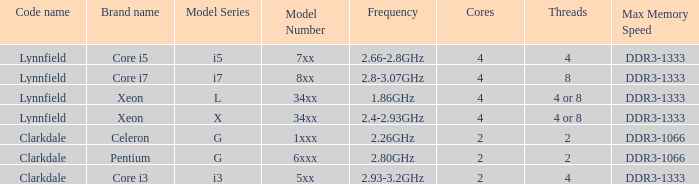What frequency does model L34xx use? 1.86GHz. 